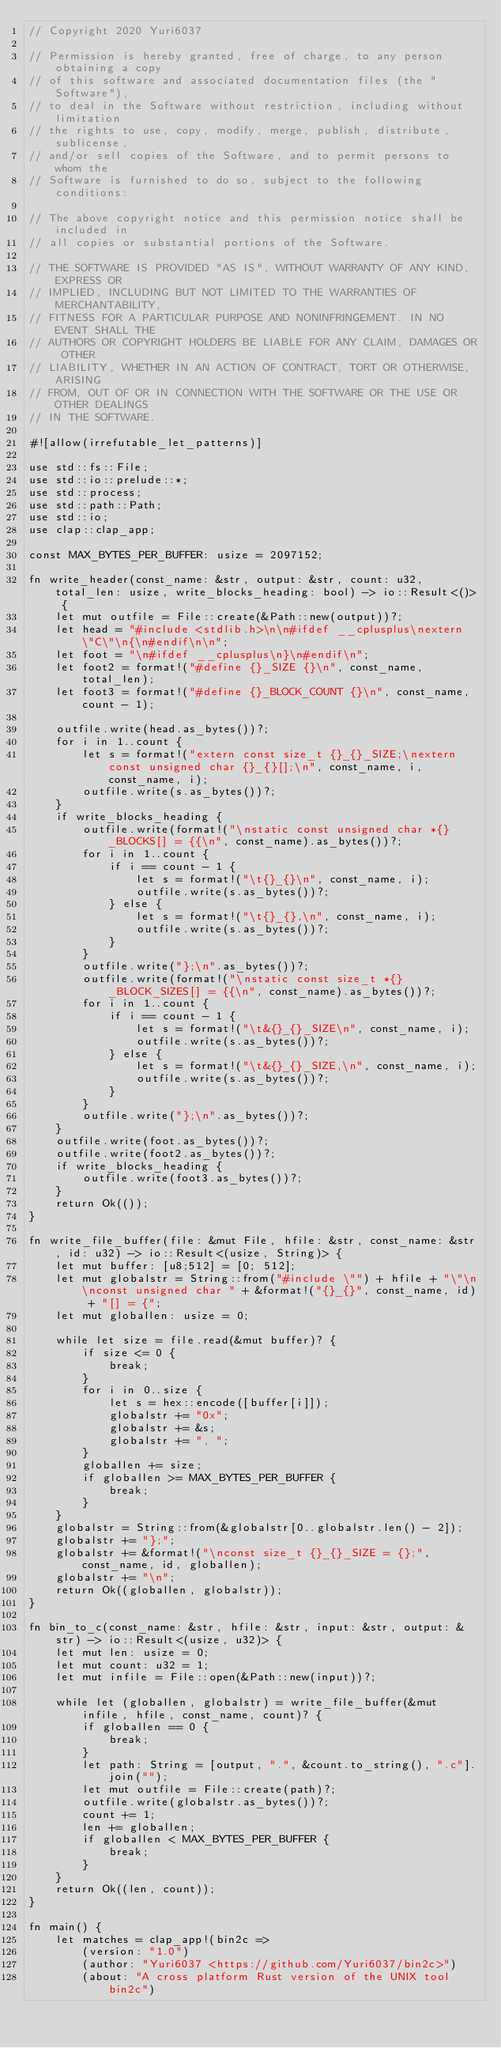<code> <loc_0><loc_0><loc_500><loc_500><_Rust_>// Copyright 2020 Yuri6037

// Permission is hereby granted, free of charge, to any person obtaining a copy
// of this software and associated documentation files (the "Software"),
// to deal in the Software without restriction, including without limitation
// the rights to use, copy, modify, merge, publish, distribute, sublicense,
// and/or sell copies of the Software, and to permit persons to whom the
// Software is furnished to do so, subject to the following conditions:

// The above copyright notice and this permission notice shall be included in
// all copies or substantial portions of the Software.

// THE SOFTWARE IS PROVIDED "AS IS", WITHOUT WARRANTY OF ANY KIND, EXPRESS OR
// IMPLIED, INCLUDING BUT NOT LIMITED TO THE WARRANTIES OF MERCHANTABILITY,
// FITNESS FOR A PARTICULAR PURPOSE AND NONINFRINGEMENT. IN NO EVENT SHALL THE
// AUTHORS OR COPYRIGHT HOLDERS BE LIABLE FOR ANY CLAIM, DAMAGES OR OTHER
// LIABILITY, WHETHER IN AN ACTION OF CONTRACT, TORT OR OTHERWISE, ARISING
// FROM, OUT OF OR IN CONNECTION WITH THE SOFTWARE OR THE USE OR OTHER DEALINGS
// IN THE SOFTWARE.

#![allow(irrefutable_let_patterns)]

use std::fs::File;
use std::io::prelude::*;
use std::process;
use std::path::Path;
use std::io;
use clap::clap_app;

const MAX_BYTES_PER_BUFFER: usize = 2097152;

fn write_header(const_name: &str, output: &str, count: u32, total_len: usize, write_blocks_heading: bool) -> io::Result<()> {
    let mut outfile = File::create(&Path::new(output))?;
    let head = "#include <stdlib.h>\n\n#ifdef __cplusplus\nextern \"C\"\n{\n#endif\n\n";
    let foot = "\n#ifdef __cplusplus\n}\n#endif\n";
    let foot2 = format!("#define {}_SIZE {}\n", const_name, total_len);
    let foot3 = format!("#define {}_BLOCK_COUNT {}\n", const_name, count - 1);

    outfile.write(head.as_bytes())?;
    for i in 1..count {
        let s = format!("extern const size_t {}_{}_SIZE;\nextern const unsigned char {}_{}[];\n", const_name, i, const_name, i);
        outfile.write(s.as_bytes())?;
    }
    if write_blocks_heading {
        outfile.write(format!("\nstatic const unsigned char *{}_BLOCKS[] = {{\n", const_name).as_bytes())?;
        for i in 1..count {
            if i == count - 1 {
                let s = format!("\t{}_{}\n", const_name, i);
                outfile.write(s.as_bytes())?;
            } else {
                let s = format!("\t{}_{},\n", const_name, i);
                outfile.write(s.as_bytes())?;
            }
        }
        outfile.write("};\n".as_bytes())?;
        outfile.write(format!("\nstatic const size_t *{}_BLOCK_SIZES[] = {{\n", const_name).as_bytes())?;
        for i in 1..count {
            if i == count - 1 {
                let s = format!("\t&{}_{}_SIZE\n", const_name, i);
                outfile.write(s.as_bytes())?;
            } else {
                let s = format!("\t&{}_{}_SIZE,\n", const_name, i);
                outfile.write(s.as_bytes())?;
            }
        }
        outfile.write("};\n".as_bytes())?;
    }
    outfile.write(foot.as_bytes())?;
    outfile.write(foot2.as_bytes())?;
    if write_blocks_heading {
        outfile.write(foot3.as_bytes())?;
    }
    return Ok(());
}

fn write_file_buffer(file: &mut File, hfile: &str, const_name: &str, id: u32) -> io::Result<(usize, String)> {
    let mut buffer: [u8;512] = [0; 512];
    let mut globalstr = String::from("#include \"") + hfile + "\"\n\nconst unsigned char " + &format!("{}_{}", const_name, id) + "[] = {";
    let mut globallen: usize = 0;

    while let size = file.read(&mut buffer)? {
        if size <= 0 {
            break;
        }
        for i in 0..size {
            let s = hex::encode([buffer[i]]);
            globalstr += "0x";
            globalstr += &s;
            globalstr += ", ";
        }
        globallen += size;
        if globallen >= MAX_BYTES_PER_BUFFER {
            break;
        }
    }
    globalstr = String::from(&globalstr[0..globalstr.len() - 2]);
    globalstr += "};";
    globalstr += &format!("\nconst size_t {}_{}_SIZE = {};", const_name, id, globallen);
    globalstr += "\n";
    return Ok((globallen, globalstr));
}

fn bin_to_c(const_name: &str, hfile: &str, input: &str, output: &str) -> io::Result<(usize, u32)> {
    let mut len: usize = 0;
    let mut count: u32 = 1;
    let mut infile = File::open(&Path::new(input))?;

    while let (globallen, globalstr) = write_file_buffer(&mut infile, hfile, const_name, count)? {
        if globallen == 0 {
            break;
        }
        let path: String = [output, ".", &count.to_string(), ".c"].join("");
        let mut outfile = File::create(path)?;
        outfile.write(globalstr.as_bytes())?;
        count += 1;
        len += globallen;
        if globallen < MAX_BYTES_PER_BUFFER {
            break;
        }
    }
    return Ok((len, count));
}

fn main() {
    let matches = clap_app!(bin2c =>
        (version: "1.0")
        (author: "Yuri6037 <https://github.com/Yuri6037/bin2c>")
        (about: "A cross platform Rust version of the UNIX tool bin2c")</code> 